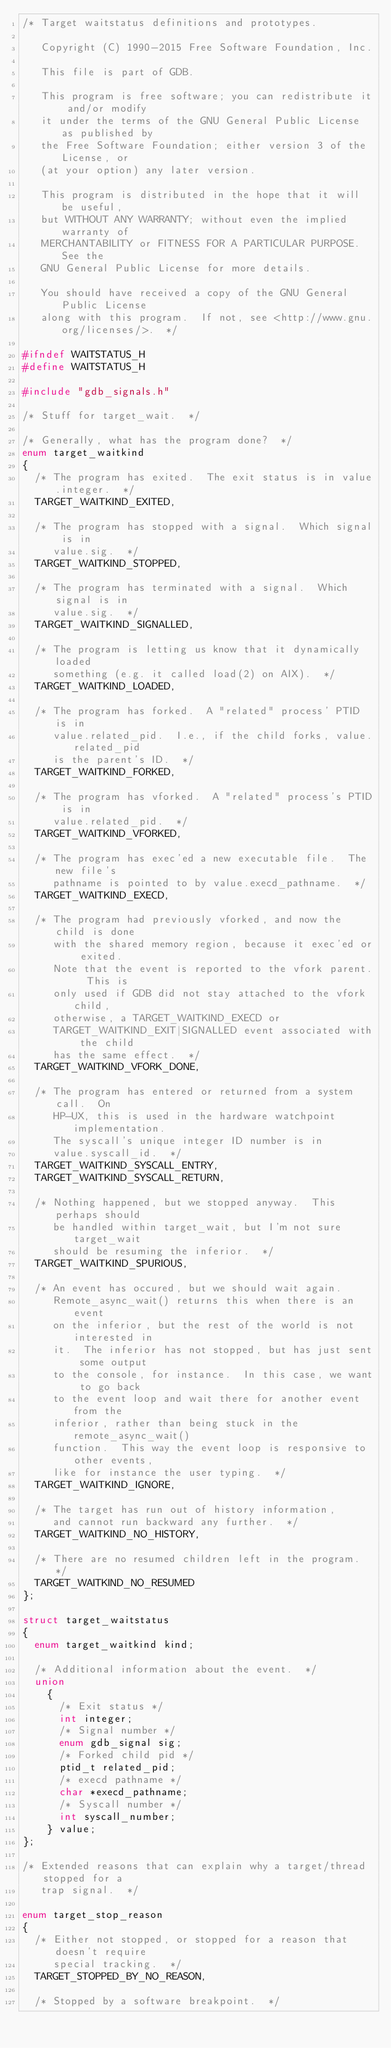Convert code to text. <code><loc_0><loc_0><loc_500><loc_500><_C_>/* Target waitstatus definitions and prototypes.

   Copyright (C) 1990-2015 Free Software Foundation, Inc.

   This file is part of GDB.

   This program is free software; you can redistribute it and/or modify
   it under the terms of the GNU General Public License as published by
   the Free Software Foundation; either version 3 of the License, or
   (at your option) any later version.

   This program is distributed in the hope that it will be useful,
   but WITHOUT ANY WARRANTY; without even the implied warranty of
   MERCHANTABILITY or FITNESS FOR A PARTICULAR PURPOSE.  See the
   GNU General Public License for more details.

   You should have received a copy of the GNU General Public License
   along with this program.  If not, see <http://www.gnu.org/licenses/>.  */

#ifndef WAITSTATUS_H
#define WAITSTATUS_H

#include "gdb_signals.h"

/* Stuff for target_wait.  */

/* Generally, what has the program done?  */
enum target_waitkind
{
  /* The program has exited.  The exit status is in value.integer.  */
  TARGET_WAITKIND_EXITED,

  /* The program has stopped with a signal.  Which signal is in
     value.sig.  */
  TARGET_WAITKIND_STOPPED,

  /* The program has terminated with a signal.  Which signal is in
     value.sig.  */
  TARGET_WAITKIND_SIGNALLED,

  /* The program is letting us know that it dynamically loaded
     something (e.g. it called load(2) on AIX).  */
  TARGET_WAITKIND_LOADED,

  /* The program has forked.  A "related" process' PTID is in
     value.related_pid.  I.e., if the child forks, value.related_pid
     is the parent's ID.  */
  TARGET_WAITKIND_FORKED,
 
  /* The program has vforked.  A "related" process's PTID is in
     value.related_pid.  */
  TARGET_WAITKIND_VFORKED,
 
  /* The program has exec'ed a new executable file.  The new file's
     pathname is pointed to by value.execd_pathname.  */
  TARGET_WAITKIND_EXECD,
  
  /* The program had previously vforked, and now the child is done
     with the shared memory region, because it exec'ed or exited.
     Note that the event is reported to the vfork parent.  This is
     only used if GDB did not stay attached to the vfork child,
     otherwise, a TARGET_WAITKIND_EXECD or
     TARGET_WAITKIND_EXIT|SIGNALLED event associated with the child
     has the same effect.  */
  TARGET_WAITKIND_VFORK_DONE,

  /* The program has entered or returned from a system call.  On
     HP-UX, this is used in the hardware watchpoint implementation.
     The syscall's unique integer ID number is in
     value.syscall_id.  */
  TARGET_WAITKIND_SYSCALL_ENTRY,
  TARGET_WAITKIND_SYSCALL_RETURN,

  /* Nothing happened, but we stopped anyway.  This perhaps should
     be handled within target_wait, but I'm not sure target_wait
     should be resuming the inferior.  */
  TARGET_WAITKIND_SPURIOUS,

  /* An event has occured, but we should wait again.
     Remote_async_wait() returns this when there is an event
     on the inferior, but the rest of the world is not interested in
     it.  The inferior has not stopped, but has just sent some output
     to the console, for instance.  In this case, we want to go back
     to the event loop and wait there for another event from the
     inferior, rather than being stuck in the remote_async_wait()
     function.  This way the event loop is responsive to other events,
     like for instance the user typing.  */
  TARGET_WAITKIND_IGNORE,
 
  /* The target has run out of history information,
     and cannot run backward any further.  */
  TARGET_WAITKIND_NO_HISTORY,
 
  /* There are no resumed children left in the program.  */
  TARGET_WAITKIND_NO_RESUMED
};

struct target_waitstatus
{
  enum target_waitkind kind;

  /* Additional information about the event.  */
  union
    {
      /* Exit status */
      int integer;
      /* Signal number */
      enum gdb_signal sig;
      /* Forked child pid */
      ptid_t related_pid;
      /* execd pathname */
      char *execd_pathname;
      /* Syscall number */
      int syscall_number;
    } value;
};

/* Extended reasons that can explain why a target/thread stopped for a
   trap signal.  */

enum target_stop_reason
{
  /* Either not stopped, or stopped for a reason that doesn't require
     special tracking.  */
  TARGET_STOPPED_BY_NO_REASON,

  /* Stopped by a software breakpoint.  */</code> 